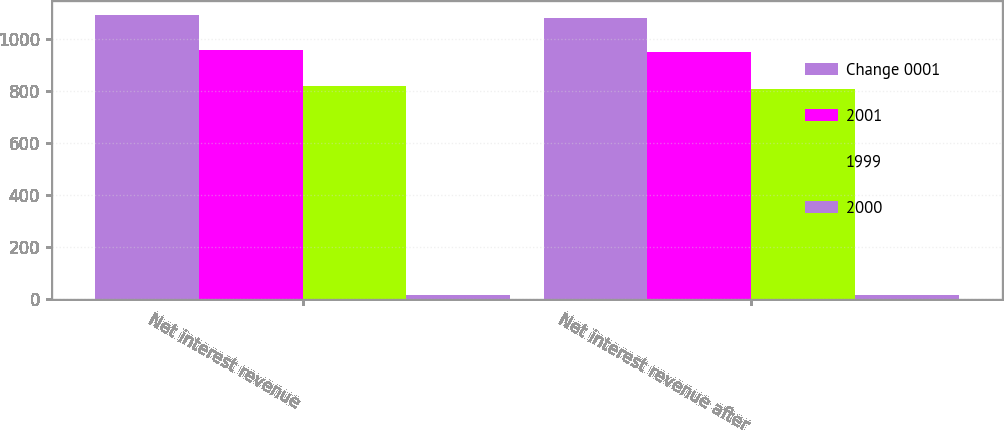<chart> <loc_0><loc_0><loc_500><loc_500><stacked_bar_chart><ecel><fcel>Net interest revenue<fcel>Net interest revenue after<nl><fcel>Change 0001<fcel>1092<fcel>1082<nl><fcel>2001<fcel>959<fcel>950<nl><fcel>1999<fcel>821<fcel>807<nl><fcel>2000<fcel>14<fcel>14<nl></chart> 